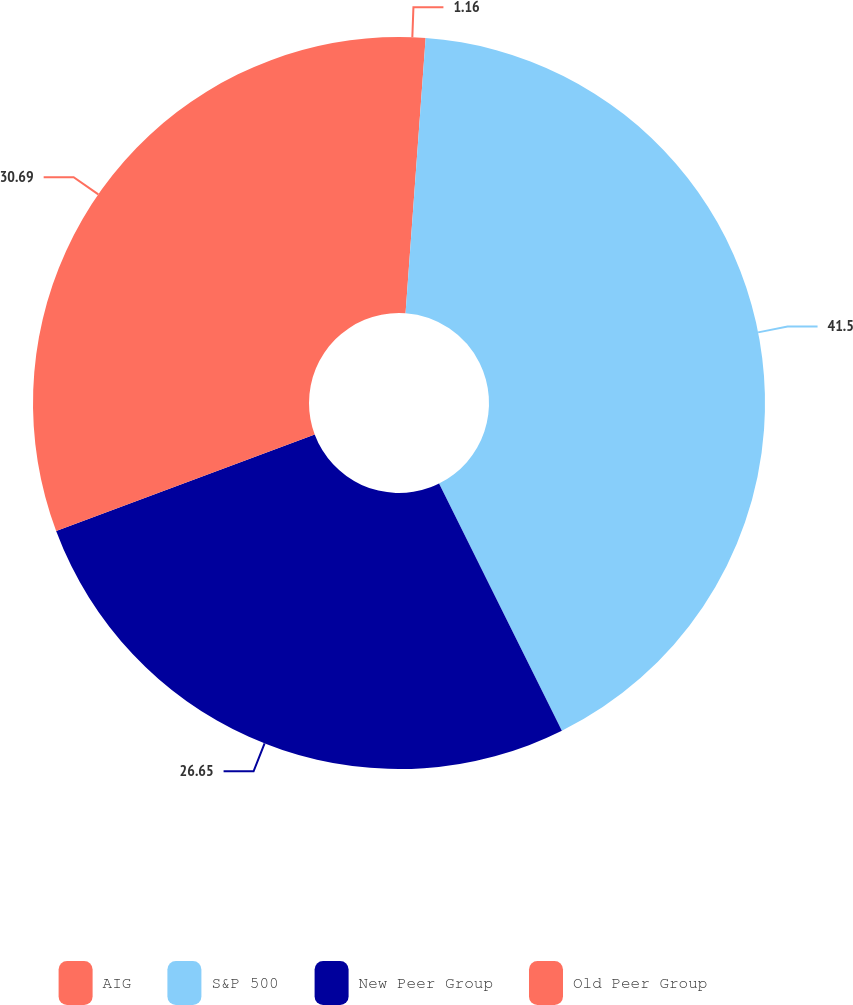<chart> <loc_0><loc_0><loc_500><loc_500><pie_chart><fcel>AIG<fcel>S&P 500<fcel>New Peer Group<fcel>Old Peer Group<nl><fcel>1.16%<fcel>41.5%<fcel>26.65%<fcel>30.69%<nl></chart> 